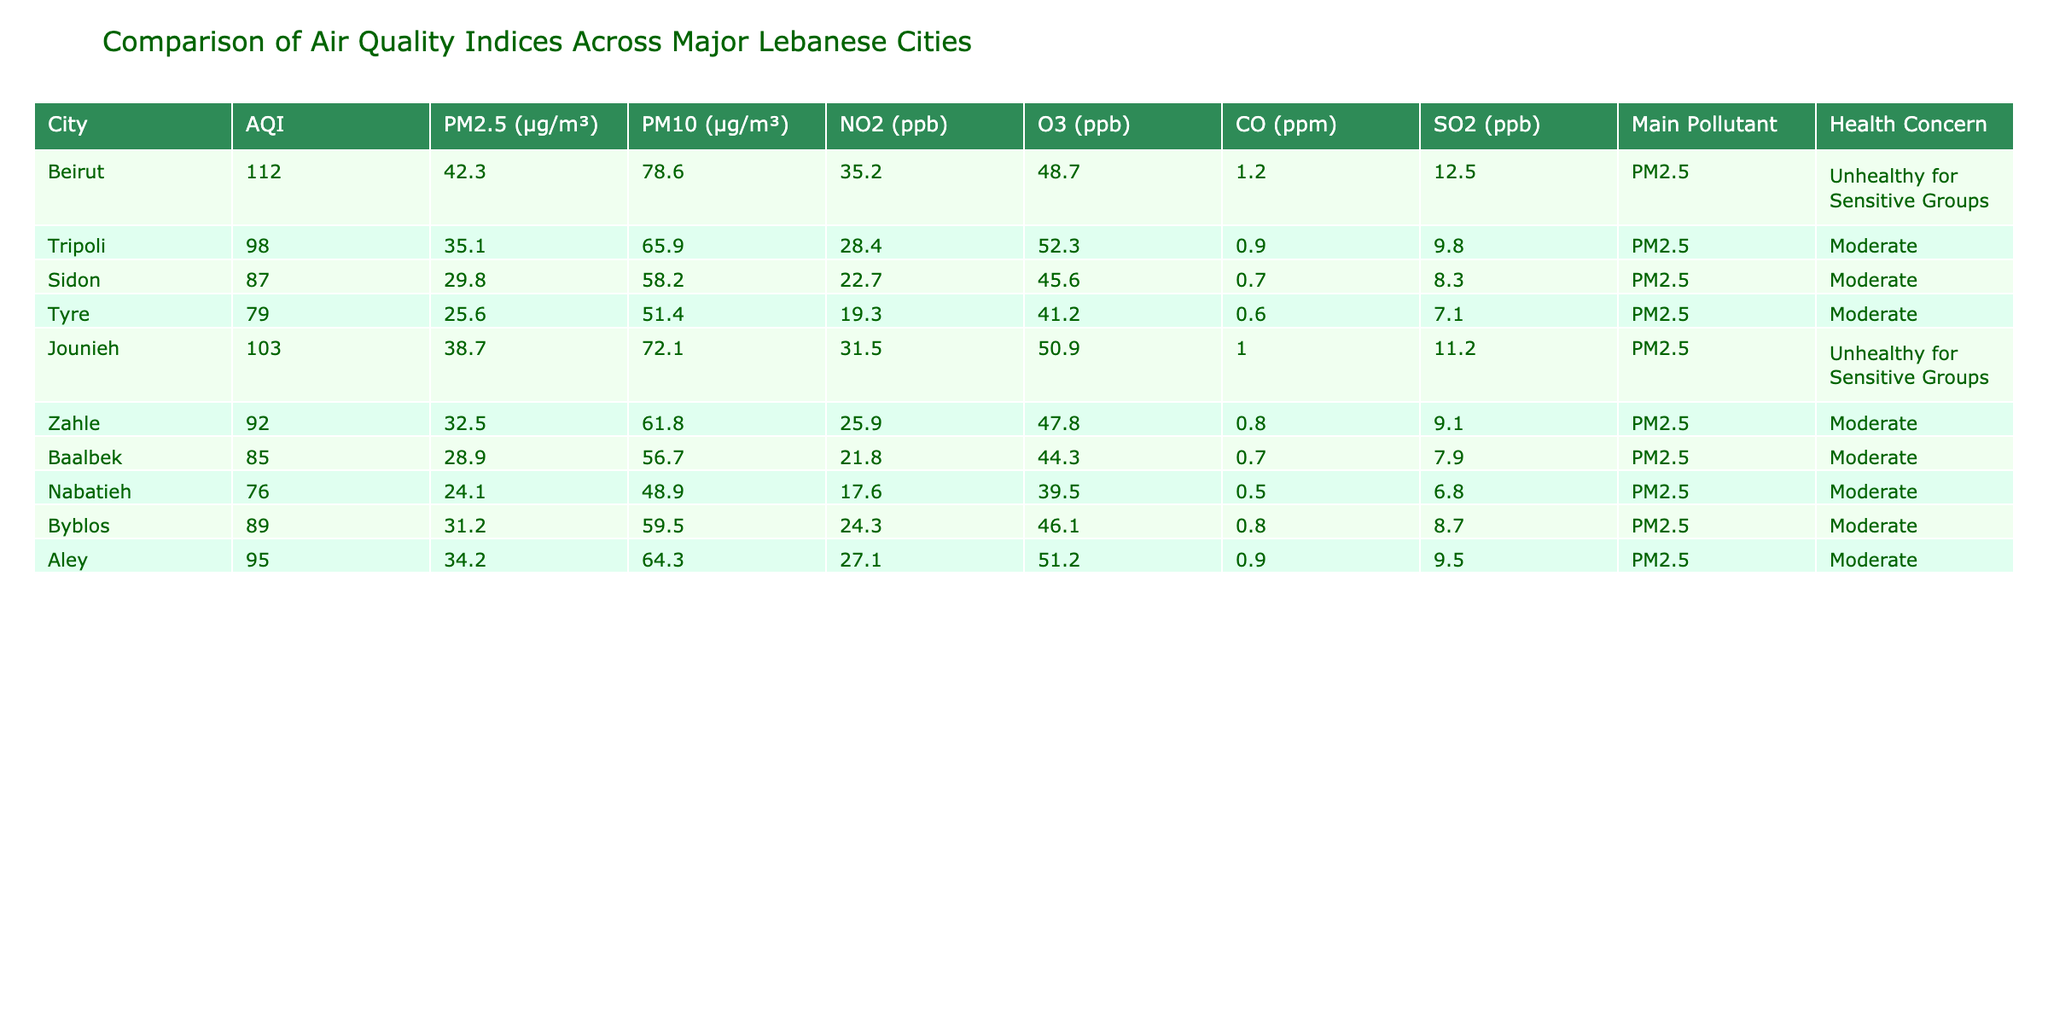What is the air quality index (AQI) for Beirut? The table indicates that the AQI for Beirut is 112. This value is taken directly from the column representing AQI for each city.
Answer: 112 Which city has the highest PM2.5 concentration? By looking at the PM2.5 values, Beirut has the highest concentration at 42.3 μg/m³, compared to other cities like Tripoli and Jounieh.
Answer: Beirut Is the main pollutant in Tripoli PM2.5? The table shows that the main pollutant for Tripoli is PM2.5, as indicated in the respective column for main pollutants.
Answer: Yes What is the difference in PM10 levels between Tyre and Sidon? The PM10 level in Tyre is 51.4 μg/m³ and in Sidon it is 58.2 μg/m³. The difference is calculated as 58.2 - 51.4 = 6.8 μg/m³.
Answer: 6.8 What is the average NO2 level across the cities listed? To calculate the average NO2 level, we sum the NO2 values: (35.2 + 28.4 + 22.7 + 19.3 + 31.5 + 25.9 + 21.8 + 17.6 + 24.3 + 27.1) =  254.8 and divide by the number of cities, which is 10. Thus, the average NO2 level is 254.8 / 10 = 25.48 ppb.
Answer: 25.48 Which cities are labeled as "Unhealthy for Sensitive Groups"? The cities identified as "Unhealthy for Sensitive Groups" in the health concern column are Beirut and Jounieh.
Answer: Beirut, Jounieh What is the maximum concentration of CO among the cities listed? Upon reviewing the CO values, the maximum concentration is found in Beirut at 1.2 ppm, which is higher than the values for the other cities.
Answer: 1.2 Is oxygen (O3) concentration higher in Nabatieh than in Sidon? The O3 concentration in Nabatieh is 39.5 ppb, while in Sidon it is 45.6 ppb. Since 39.5 is less than 45.6, the statement is false.
Answer: No What is the health concern classification for the city with the lowest AQI? The city with the lowest AQI is Tyre at 79. The health concern classification for Tyre is "Moderate", as stated in the respective column.
Answer: Moderate 